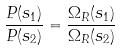<formula> <loc_0><loc_0><loc_500><loc_500>\frac { P ( s _ { 1 } ) } { P ( s _ { 2 } ) } = \frac { \Omega _ { R } ( s _ { 1 } ) } { \Omega _ { R } ( s _ { 2 } ) }</formula> 